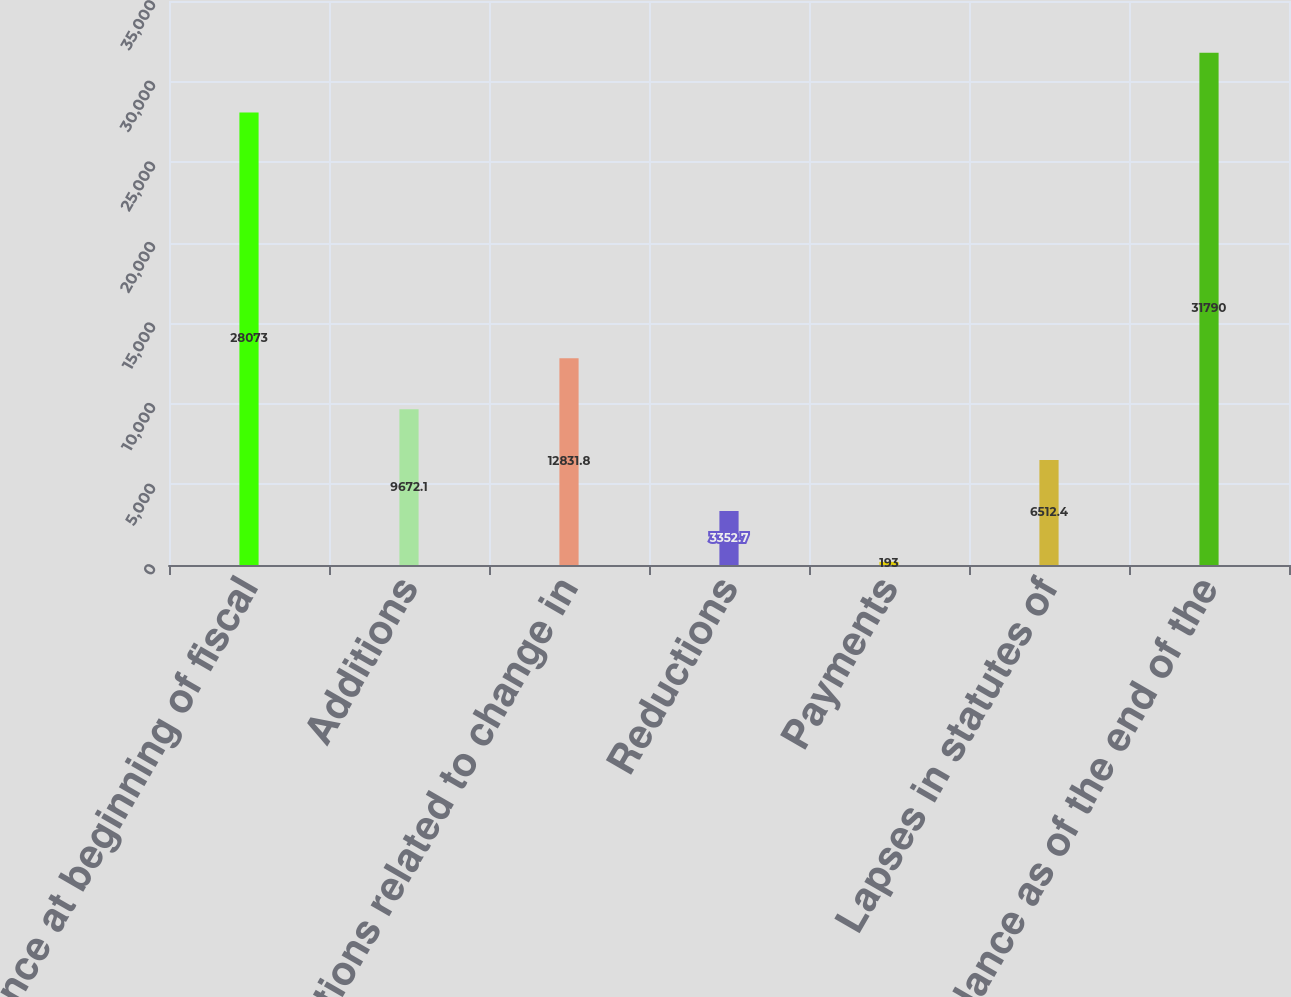Convert chart. <chart><loc_0><loc_0><loc_500><loc_500><bar_chart><fcel>Balance at beginning of fiscal<fcel>Additions<fcel>Additions related to change in<fcel>Reductions<fcel>Payments<fcel>Lapses in statutes of<fcel>Balance as of the end of the<nl><fcel>28073<fcel>9672.1<fcel>12831.8<fcel>3352.7<fcel>193<fcel>6512.4<fcel>31790<nl></chart> 